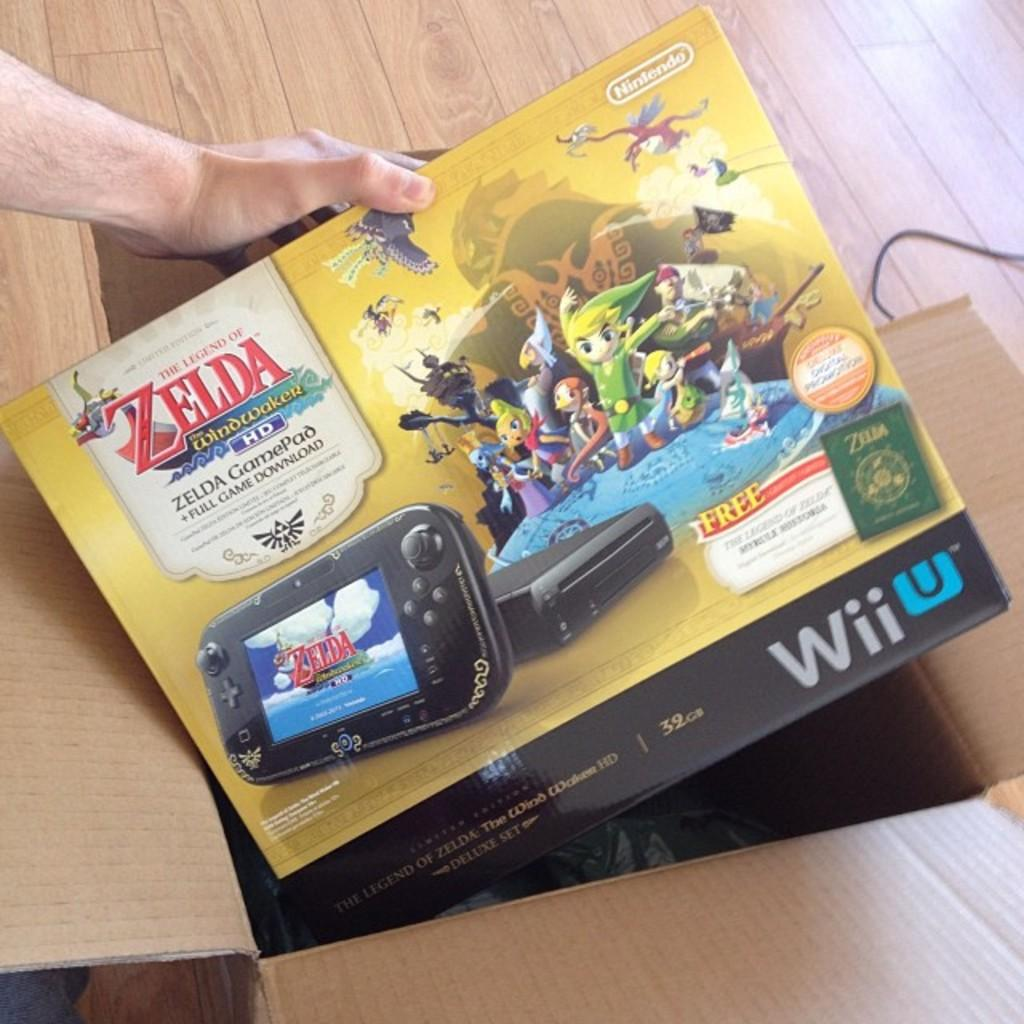Provide a one-sentence caption for the provided image. Someone takes a Zelda GamePad out of a cardboard box. 